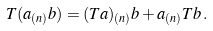<formula> <loc_0><loc_0><loc_500><loc_500>T ( a _ { ( n ) } b ) = ( T a ) _ { ( n ) } b + a _ { ( n ) } T b \, .</formula> 